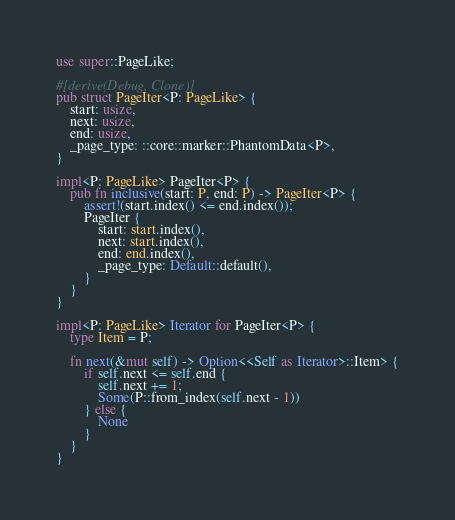<code> <loc_0><loc_0><loc_500><loc_500><_Rust_>use super::PageLike;

#[derive(Debug, Clone)]
pub struct PageIter<P: PageLike> {
	start: usize,
	next: usize,
	end: usize,
	_page_type: ::core::marker::PhantomData<P>,
}

impl<P: PageLike> PageIter<P> {
	pub fn inclusive(start: P, end: P) -> PageIter<P> {
		assert!(start.index() <= end.index());
		PageIter {
			start: start.index(),
			next: start.index(),
			end: end.index(),
			_page_type: Default::default(),
		}
	}
}

impl<P: PageLike> Iterator for PageIter<P> {
	type Item = P;

	fn next(&mut self) -> Option<<Self as Iterator>::Item> {
		if self.next <= self.end {
			self.next += 1;
			Some(P::from_index(self.next - 1))
		} else {
			None
		}
	}
}
</code> 